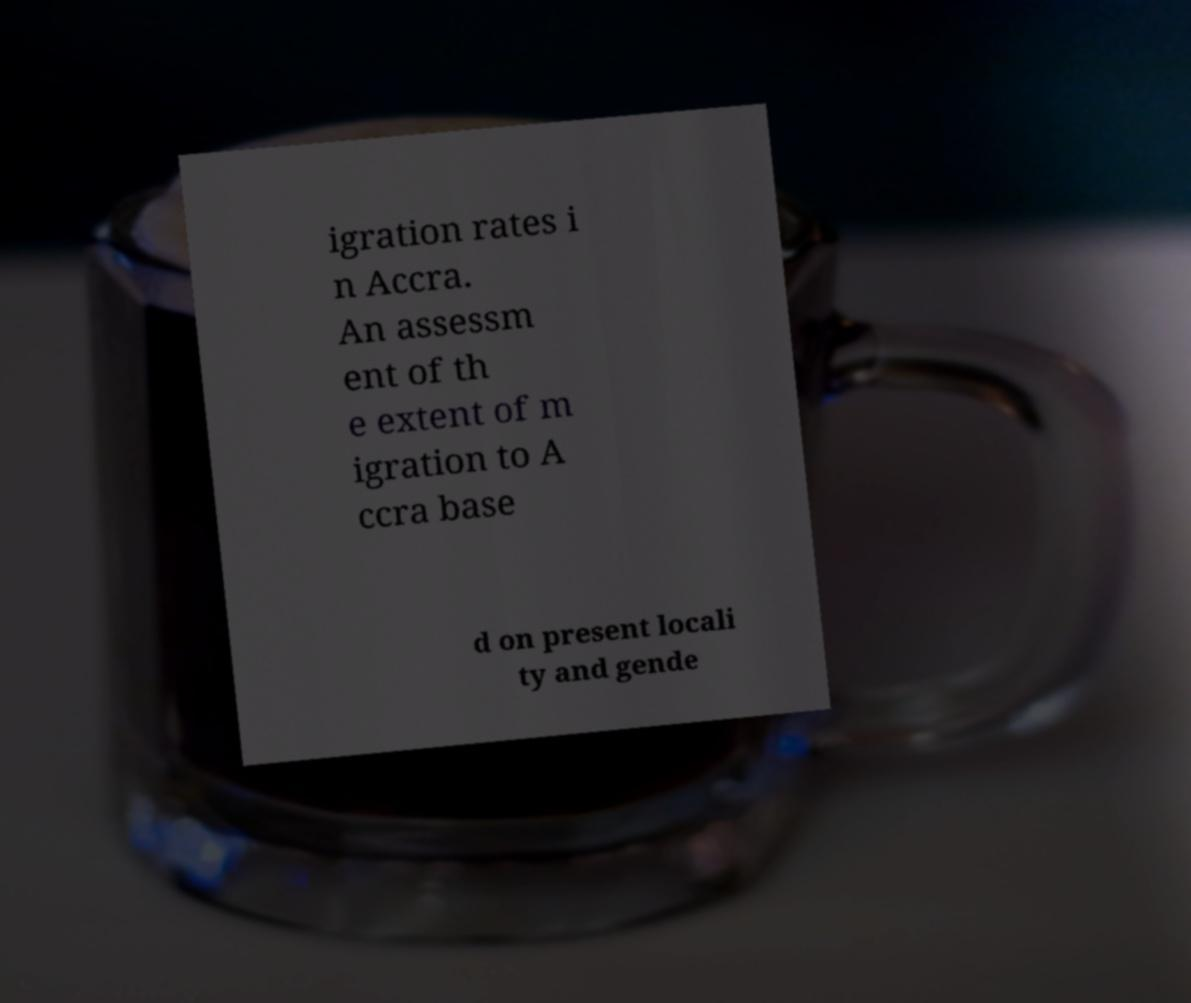Please read and relay the text visible in this image. What does it say? igration rates i n Accra. An assessm ent of th e extent of m igration to A ccra base d on present locali ty and gende 